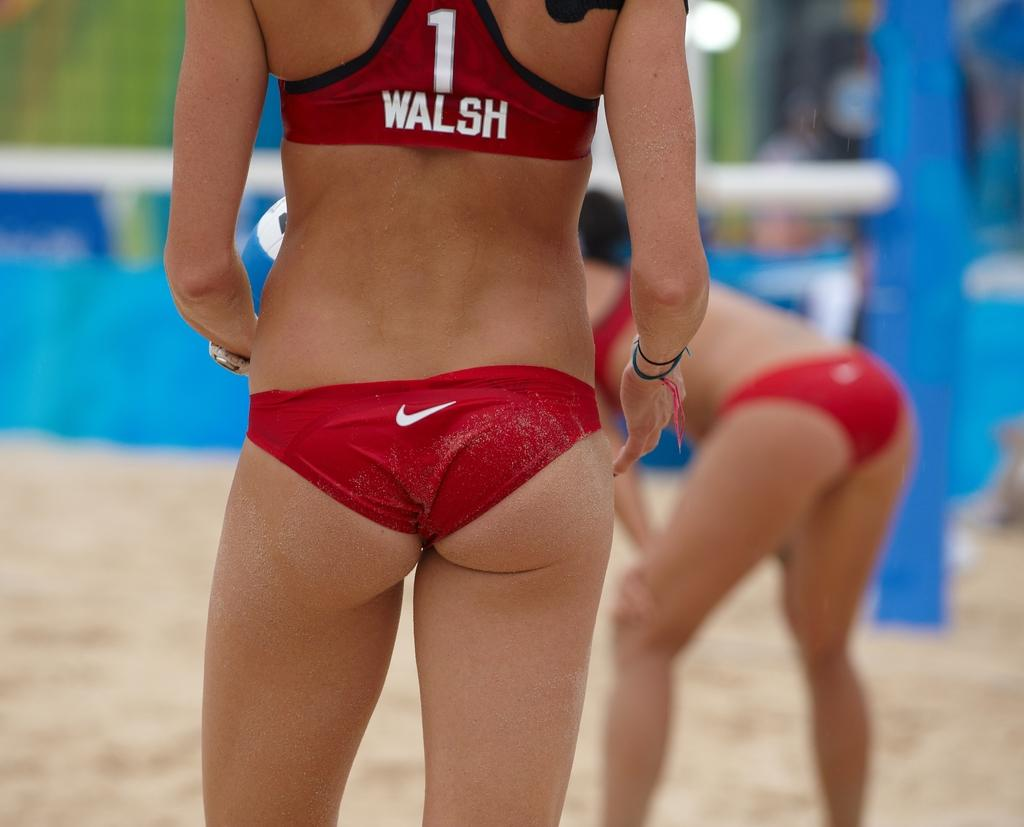<image>
Describe the image concisely. A woman named Walsh wears a small, red, tight bikini. 